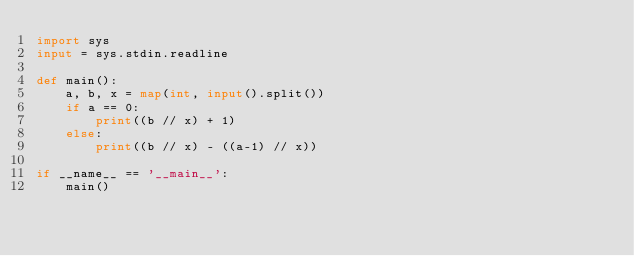Convert code to text. <code><loc_0><loc_0><loc_500><loc_500><_Python_>import sys
input = sys.stdin.readline

def main():
    a, b, x = map(int, input().split())
    if a == 0:
        print((b // x) + 1)
    else:
        print((b // x) - ((a-1) // x))

if __name__ == '__main__':
    main()
</code> 